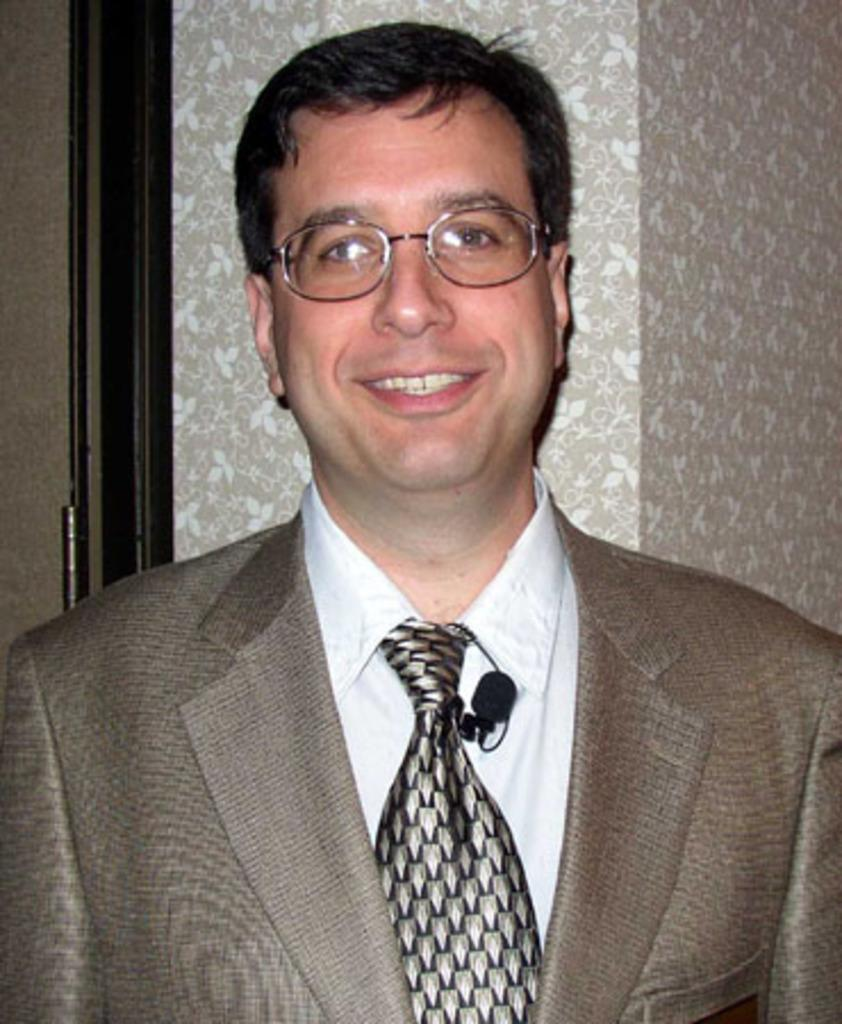Who is the main subject in the image? There is a man in the image. What is the man wearing? The man is wearing a brown suit. Where is the man positioned in the image? The man is standing in the front. What is the man's facial expression in the image? The man is smiling. What is the man doing in the image? The man is giving a pose into the camera. What can be seen on the wall in the background? There is a wallpaper on the wall in the background. What architectural feature is visible in the background? There is a door in the background. Can you describe the woman holding a jellyfish in the image? There is no woman or jellyfish present in the image; it features a man in a brown suit. 